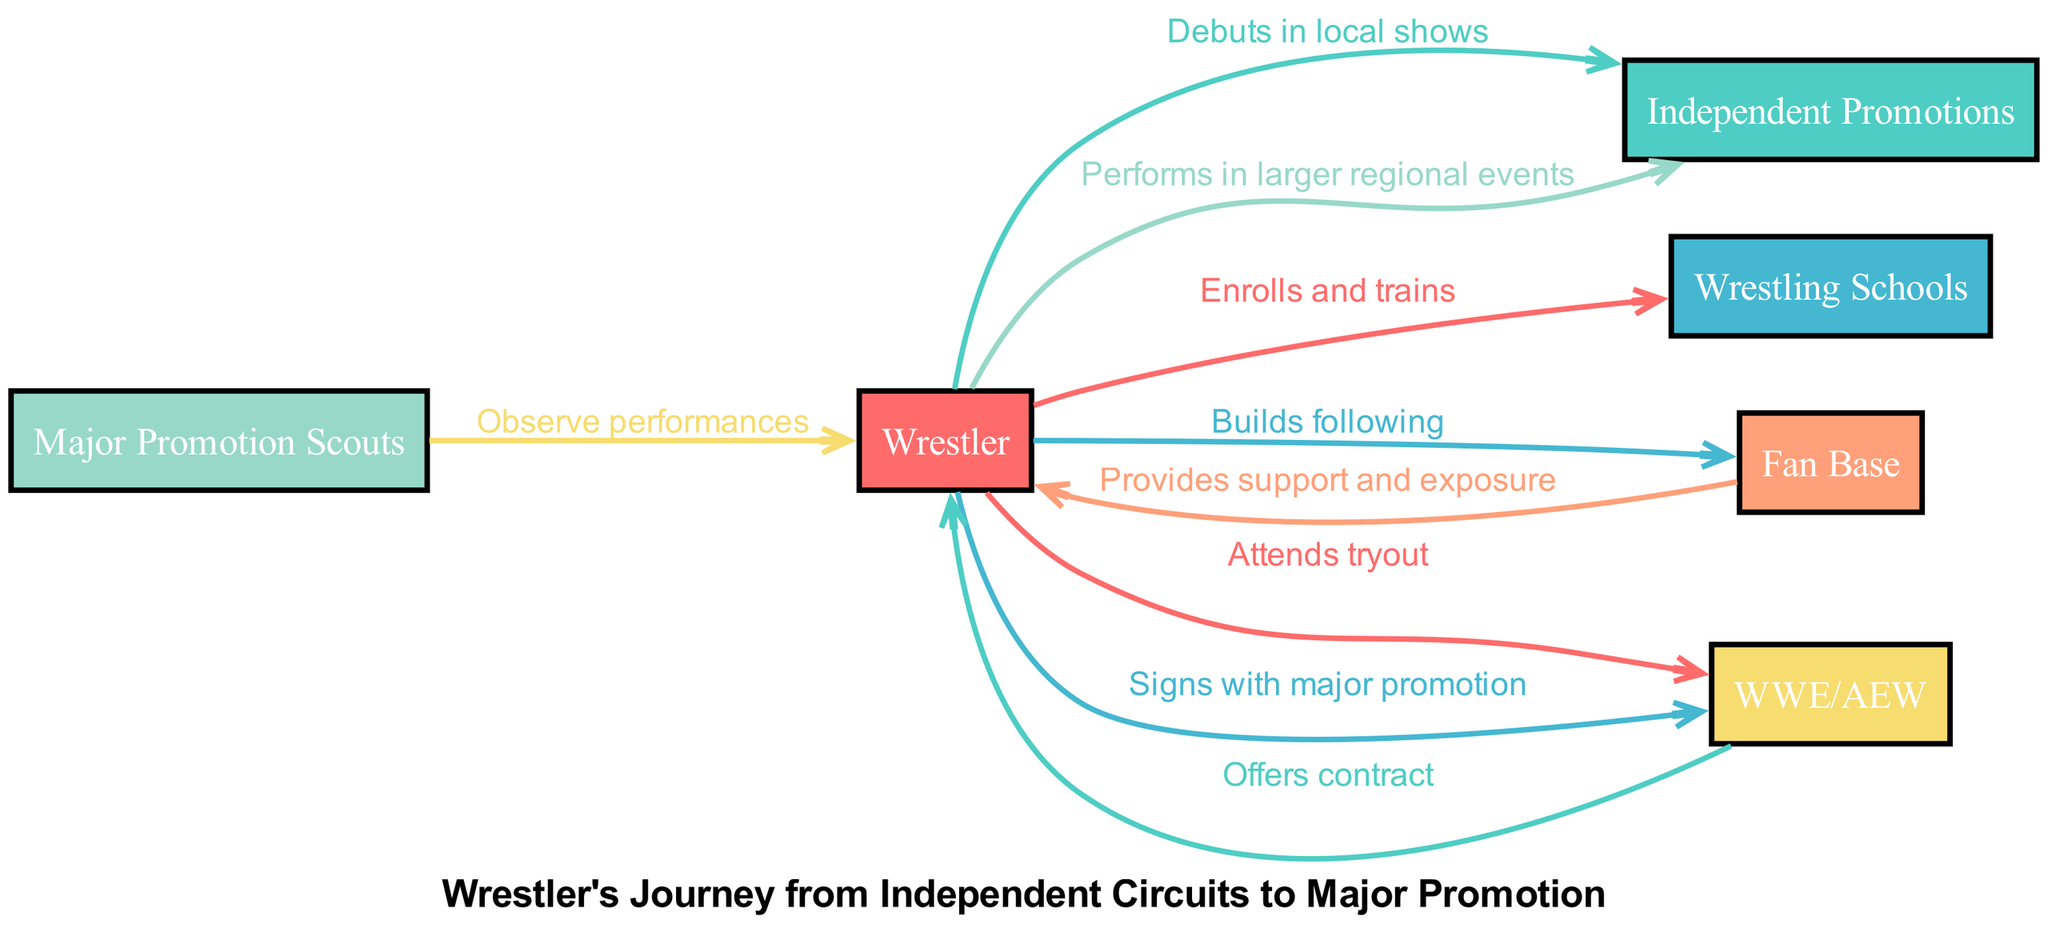What's the first step in the wrestler's journey? The first step in the journey is the wrestler enrolling and training at wrestling schools. This is indicated as the initial action in the sequence.
Answer: Enrolls and trains How many actors are involved in the diagram? By counting the nodes representing the actors (Wrestler, Independent Promotions, Wrestling Schools, Fan Base, Major Promotion Scouts, WWE/AEW), we find there are six actors.
Answer: 6 What is the relationship between the Wrestler and the Fan Base? The diagram shows that the Wrestler builds a following with the Fan Base, and in return, the Fan Base provides support and exposure to the Wrestler, indicating a reciprocal relationship.
Answer: Builds following How many actions does the Wrestler perform in the journey? The diagram outlines three actions performed by the Wrestler: enrolling in wrestling schools, debuting in local shows, and signing with a major promotion. By tracking these actions in the sequence, we find three distinct actions.
Answer: 3 Which actor observes the Wrestler's performances? In the sequence, the Major Promotion Scouts are shown observing the performance of the Wrestler, making them the specific actor responsible for this action.
Answer: Major Promotion Scouts What happens after the Wrestler attends a tryout? After the Wrestler attends a tryout, the next action in the sequence is that WWE/AEW offers a contract to the Wrestler, indicating a progression towards signing.
Answer: Offers contract What role does the Fan Base play in the wrestler's journey? The Fan Base plays an essential role by providing support and exposure to the Wrestler, which helps increase their popularity and visibility in the wrestling circuit.
Answer: Provides support and exposure How does the wrestler transition to larger events? The Wrestler progresses to performing in larger regional events after debuting in local shows, which is a step that showcases the evolution of their career and skill level.
Answer: Performs in larger regional events What does the diagram illustrate about the final outcome for the Wrestler? The final outcome illustrated is that the Wrestler signs with a major promotion (WWE/AEW), demonstrating the successful completion of their journey from independent circuits to a major wrestling organization.
Answer: Signs with major promotion 